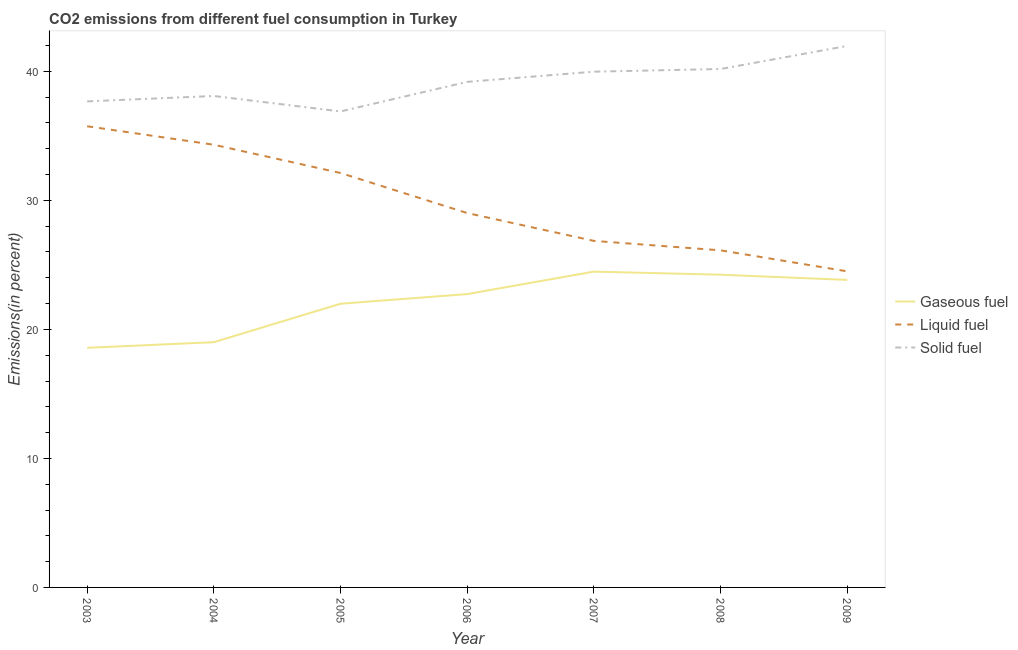Is the number of lines equal to the number of legend labels?
Your answer should be very brief. Yes. What is the percentage of gaseous fuel emission in 2006?
Provide a succinct answer. 22.74. Across all years, what is the maximum percentage of liquid fuel emission?
Make the answer very short. 35.75. Across all years, what is the minimum percentage of liquid fuel emission?
Your response must be concise. 24.5. What is the total percentage of solid fuel emission in the graph?
Provide a succinct answer. 273.98. What is the difference between the percentage of liquid fuel emission in 2006 and that in 2008?
Your answer should be compact. 2.89. What is the difference between the percentage of solid fuel emission in 2008 and the percentage of liquid fuel emission in 2003?
Your response must be concise. 4.44. What is the average percentage of solid fuel emission per year?
Offer a terse response. 39.14. In the year 2003, what is the difference between the percentage of gaseous fuel emission and percentage of solid fuel emission?
Give a very brief answer. -19.1. In how many years, is the percentage of gaseous fuel emission greater than 22 %?
Your answer should be compact. 4. What is the ratio of the percentage of solid fuel emission in 2007 to that in 2009?
Give a very brief answer. 0.95. Is the percentage of solid fuel emission in 2003 less than that in 2005?
Give a very brief answer. No. What is the difference between the highest and the second highest percentage of solid fuel emission?
Ensure brevity in your answer.  1.79. What is the difference between the highest and the lowest percentage of liquid fuel emission?
Offer a terse response. 11.25. Is it the case that in every year, the sum of the percentage of gaseous fuel emission and percentage of liquid fuel emission is greater than the percentage of solid fuel emission?
Your answer should be very brief. Yes. Does the percentage of solid fuel emission monotonically increase over the years?
Provide a succinct answer. No. Is the percentage of solid fuel emission strictly less than the percentage of gaseous fuel emission over the years?
Offer a very short reply. No. Where does the legend appear in the graph?
Your answer should be compact. Center right. How many legend labels are there?
Your response must be concise. 3. How are the legend labels stacked?
Give a very brief answer. Vertical. What is the title of the graph?
Give a very brief answer. CO2 emissions from different fuel consumption in Turkey. Does "Coal sources" appear as one of the legend labels in the graph?
Offer a terse response. No. What is the label or title of the Y-axis?
Offer a terse response. Emissions(in percent). What is the Emissions(in percent) of Gaseous fuel in 2003?
Offer a very short reply. 18.57. What is the Emissions(in percent) in Liquid fuel in 2003?
Your answer should be compact. 35.75. What is the Emissions(in percent) in Solid fuel in 2003?
Keep it short and to the point. 37.67. What is the Emissions(in percent) in Gaseous fuel in 2004?
Keep it short and to the point. 19.01. What is the Emissions(in percent) in Liquid fuel in 2004?
Keep it short and to the point. 34.31. What is the Emissions(in percent) in Solid fuel in 2004?
Provide a short and direct response. 38.09. What is the Emissions(in percent) of Gaseous fuel in 2005?
Offer a terse response. 21.99. What is the Emissions(in percent) in Liquid fuel in 2005?
Provide a short and direct response. 32.12. What is the Emissions(in percent) of Solid fuel in 2005?
Your answer should be compact. 36.9. What is the Emissions(in percent) of Gaseous fuel in 2006?
Your answer should be compact. 22.74. What is the Emissions(in percent) in Liquid fuel in 2006?
Give a very brief answer. 29.02. What is the Emissions(in percent) of Solid fuel in 2006?
Offer a very short reply. 39.19. What is the Emissions(in percent) of Gaseous fuel in 2007?
Offer a terse response. 24.48. What is the Emissions(in percent) of Liquid fuel in 2007?
Provide a short and direct response. 26.86. What is the Emissions(in percent) of Solid fuel in 2007?
Your answer should be very brief. 39.98. What is the Emissions(in percent) of Gaseous fuel in 2008?
Your response must be concise. 24.24. What is the Emissions(in percent) in Liquid fuel in 2008?
Keep it short and to the point. 26.13. What is the Emissions(in percent) of Solid fuel in 2008?
Offer a very short reply. 40.18. What is the Emissions(in percent) of Gaseous fuel in 2009?
Offer a very short reply. 23.84. What is the Emissions(in percent) of Liquid fuel in 2009?
Offer a very short reply. 24.5. What is the Emissions(in percent) in Solid fuel in 2009?
Your answer should be compact. 41.97. Across all years, what is the maximum Emissions(in percent) in Gaseous fuel?
Offer a terse response. 24.48. Across all years, what is the maximum Emissions(in percent) in Liquid fuel?
Your answer should be compact. 35.75. Across all years, what is the maximum Emissions(in percent) in Solid fuel?
Your answer should be very brief. 41.97. Across all years, what is the minimum Emissions(in percent) in Gaseous fuel?
Give a very brief answer. 18.57. Across all years, what is the minimum Emissions(in percent) of Liquid fuel?
Give a very brief answer. 24.5. Across all years, what is the minimum Emissions(in percent) of Solid fuel?
Make the answer very short. 36.9. What is the total Emissions(in percent) of Gaseous fuel in the graph?
Offer a terse response. 154.86. What is the total Emissions(in percent) in Liquid fuel in the graph?
Give a very brief answer. 208.69. What is the total Emissions(in percent) in Solid fuel in the graph?
Your answer should be very brief. 273.98. What is the difference between the Emissions(in percent) of Gaseous fuel in 2003 and that in 2004?
Offer a very short reply. -0.44. What is the difference between the Emissions(in percent) in Liquid fuel in 2003 and that in 2004?
Your answer should be very brief. 1.43. What is the difference between the Emissions(in percent) in Solid fuel in 2003 and that in 2004?
Your answer should be very brief. -0.42. What is the difference between the Emissions(in percent) of Gaseous fuel in 2003 and that in 2005?
Offer a very short reply. -3.42. What is the difference between the Emissions(in percent) of Liquid fuel in 2003 and that in 2005?
Your answer should be compact. 3.62. What is the difference between the Emissions(in percent) in Solid fuel in 2003 and that in 2005?
Keep it short and to the point. 0.78. What is the difference between the Emissions(in percent) in Gaseous fuel in 2003 and that in 2006?
Your answer should be very brief. -4.17. What is the difference between the Emissions(in percent) of Liquid fuel in 2003 and that in 2006?
Ensure brevity in your answer.  6.73. What is the difference between the Emissions(in percent) of Solid fuel in 2003 and that in 2006?
Give a very brief answer. -1.51. What is the difference between the Emissions(in percent) in Gaseous fuel in 2003 and that in 2007?
Keep it short and to the point. -5.91. What is the difference between the Emissions(in percent) of Liquid fuel in 2003 and that in 2007?
Offer a terse response. 8.88. What is the difference between the Emissions(in percent) of Solid fuel in 2003 and that in 2007?
Give a very brief answer. -2.3. What is the difference between the Emissions(in percent) in Gaseous fuel in 2003 and that in 2008?
Keep it short and to the point. -5.67. What is the difference between the Emissions(in percent) in Liquid fuel in 2003 and that in 2008?
Ensure brevity in your answer.  9.62. What is the difference between the Emissions(in percent) of Solid fuel in 2003 and that in 2008?
Make the answer very short. -2.51. What is the difference between the Emissions(in percent) in Gaseous fuel in 2003 and that in 2009?
Provide a succinct answer. -5.26. What is the difference between the Emissions(in percent) of Liquid fuel in 2003 and that in 2009?
Offer a very short reply. 11.25. What is the difference between the Emissions(in percent) in Solid fuel in 2003 and that in 2009?
Ensure brevity in your answer.  -4.3. What is the difference between the Emissions(in percent) in Gaseous fuel in 2004 and that in 2005?
Your answer should be very brief. -2.98. What is the difference between the Emissions(in percent) in Liquid fuel in 2004 and that in 2005?
Your answer should be compact. 2.19. What is the difference between the Emissions(in percent) in Solid fuel in 2004 and that in 2005?
Your answer should be compact. 1.2. What is the difference between the Emissions(in percent) of Gaseous fuel in 2004 and that in 2006?
Offer a very short reply. -3.73. What is the difference between the Emissions(in percent) of Liquid fuel in 2004 and that in 2006?
Offer a very short reply. 5.3. What is the difference between the Emissions(in percent) in Solid fuel in 2004 and that in 2006?
Provide a short and direct response. -1.09. What is the difference between the Emissions(in percent) in Gaseous fuel in 2004 and that in 2007?
Offer a very short reply. -5.47. What is the difference between the Emissions(in percent) in Liquid fuel in 2004 and that in 2007?
Ensure brevity in your answer.  7.45. What is the difference between the Emissions(in percent) in Solid fuel in 2004 and that in 2007?
Offer a very short reply. -1.88. What is the difference between the Emissions(in percent) of Gaseous fuel in 2004 and that in 2008?
Offer a very short reply. -5.23. What is the difference between the Emissions(in percent) in Liquid fuel in 2004 and that in 2008?
Offer a very short reply. 8.19. What is the difference between the Emissions(in percent) in Solid fuel in 2004 and that in 2008?
Provide a short and direct response. -2.09. What is the difference between the Emissions(in percent) in Gaseous fuel in 2004 and that in 2009?
Your answer should be compact. -4.83. What is the difference between the Emissions(in percent) of Liquid fuel in 2004 and that in 2009?
Give a very brief answer. 9.81. What is the difference between the Emissions(in percent) of Solid fuel in 2004 and that in 2009?
Make the answer very short. -3.88. What is the difference between the Emissions(in percent) of Gaseous fuel in 2005 and that in 2006?
Provide a succinct answer. -0.75. What is the difference between the Emissions(in percent) in Liquid fuel in 2005 and that in 2006?
Offer a very short reply. 3.1. What is the difference between the Emissions(in percent) of Solid fuel in 2005 and that in 2006?
Provide a short and direct response. -2.29. What is the difference between the Emissions(in percent) of Gaseous fuel in 2005 and that in 2007?
Your answer should be compact. -2.49. What is the difference between the Emissions(in percent) in Liquid fuel in 2005 and that in 2007?
Your answer should be compact. 5.26. What is the difference between the Emissions(in percent) in Solid fuel in 2005 and that in 2007?
Give a very brief answer. -3.08. What is the difference between the Emissions(in percent) of Gaseous fuel in 2005 and that in 2008?
Make the answer very short. -2.25. What is the difference between the Emissions(in percent) of Liquid fuel in 2005 and that in 2008?
Provide a succinct answer. 5.99. What is the difference between the Emissions(in percent) in Solid fuel in 2005 and that in 2008?
Offer a terse response. -3.29. What is the difference between the Emissions(in percent) in Gaseous fuel in 2005 and that in 2009?
Offer a terse response. -1.85. What is the difference between the Emissions(in percent) of Liquid fuel in 2005 and that in 2009?
Provide a succinct answer. 7.62. What is the difference between the Emissions(in percent) in Solid fuel in 2005 and that in 2009?
Give a very brief answer. -5.08. What is the difference between the Emissions(in percent) of Gaseous fuel in 2006 and that in 2007?
Give a very brief answer. -1.74. What is the difference between the Emissions(in percent) of Liquid fuel in 2006 and that in 2007?
Keep it short and to the point. 2.16. What is the difference between the Emissions(in percent) in Solid fuel in 2006 and that in 2007?
Provide a short and direct response. -0.79. What is the difference between the Emissions(in percent) of Gaseous fuel in 2006 and that in 2008?
Your answer should be very brief. -1.5. What is the difference between the Emissions(in percent) of Liquid fuel in 2006 and that in 2008?
Offer a very short reply. 2.89. What is the difference between the Emissions(in percent) in Solid fuel in 2006 and that in 2008?
Provide a short and direct response. -1. What is the difference between the Emissions(in percent) of Gaseous fuel in 2006 and that in 2009?
Provide a succinct answer. -1.1. What is the difference between the Emissions(in percent) of Liquid fuel in 2006 and that in 2009?
Make the answer very short. 4.52. What is the difference between the Emissions(in percent) in Solid fuel in 2006 and that in 2009?
Make the answer very short. -2.79. What is the difference between the Emissions(in percent) in Gaseous fuel in 2007 and that in 2008?
Ensure brevity in your answer.  0.24. What is the difference between the Emissions(in percent) of Liquid fuel in 2007 and that in 2008?
Your response must be concise. 0.73. What is the difference between the Emissions(in percent) in Solid fuel in 2007 and that in 2008?
Your response must be concise. -0.21. What is the difference between the Emissions(in percent) of Gaseous fuel in 2007 and that in 2009?
Provide a succinct answer. 0.64. What is the difference between the Emissions(in percent) in Liquid fuel in 2007 and that in 2009?
Give a very brief answer. 2.36. What is the difference between the Emissions(in percent) of Solid fuel in 2007 and that in 2009?
Your response must be concise. -2. What is the difference between the Emissions(in percent) of Gaseous fuel in 2008 and that in 2009?
Provide a short and direct response. 0.4. What is the difference between the Emissions(in percent) in Liquid fuel in 2008 and that in 2009?
Your answer should be very brief. 1.63. What is the difference between the Emissions(in percent) of Solid fuel in 2008 and that in 2009?
Your answer should be very brief. -1.79. What is the difference between the Emissions(in percent) of Gaseous fuel in 2003 and the Emissions(in percent) of Liquid fuel in 2004?
Your response must be concise. -15.74. What is the difference between the Emissions(in percent) of Gaseous fuel in 2003 and the Emissions(in percent) of Solid fuel in 2004?
Ensure brevity in your answer.  -19.52. What is the difference between the Emissions(in percent) in Liquid fuel in 2003 and the Emissions(in percent) in Solid fuel in 2004?
Offer a very short reply. -2.35. What is the difference between the Emissions(in percent) of Gaseous fuel in 2003 and the Emissions(in percent) of Liquid fuel in 2005?
Offer a terse response. -13.55. What is the difference between the Emissions(in percent) in Gaseous fuel in 2003 and the Emissions(in percent) in Solid fuel in 2005?
Give a very brief answer. -18.32. What is the difference between the Emissions(in percent) of Liquid fuel in 2003 and the Emissions(in percent) of Solid fuel in 2005?
Offer a very short reply. -1.15. What is the difference between the Emissions(in percent) of Gaseous fuel in 2003 and the Emissions(in percent) of Liquid fuel in 2006?
Give a very brief answer. -10.45. What is the difference between the Emissions(in percent) in Gaseous fuel in 2003 and the Emissions(in percent) in Solid fuel in 2006?
Give a very brief answer. -20.61. What is the difference between the Emissions(in percent) in Liquid fuel in 2003 and the Emissions(in percent) in Solid fuel in 2006?
Give a very brief answer. -3.44. What is the difference between the Emissions(in percent) of Gaseous fuel in 2003 and the Emissions(in percent) of Liquid fuel in 2007?
Give a very brief answer. -8.29. What is the difference between the Emissions(in percent) in Gaseous fuel in 2003 and the Emissions(in percent) in Solid fuel in 2007?
Your answer should be compact. -21.4. What is the difference between the Emissions(in percent) in Liquid fuel in 2003 and the Emissions(in percent) in Solid fuel in 2007?
Make the answer very short. -4.23. What is the difference between the Emissions(in percent) in Gaseous fuel in 2003 and the Emissions(in percent) in Liquid fuel in 2008?
Provide a succinct answer. -7.56. What is the difference between the Emissions(in percent) of Gaseous fuel in 2003 and the Emissions(in percent) of Solid fuel in 2008?
Ensure brevity in your answer.  -21.61. What is the difference between the Emissions(in percent) of Liquid fuel in 2003 and the Emissions(in percent) of Solid fuel in 2008?
Your answer should be compact. -4.44. What is the difference between the Emissions(in percent) of Gaseous fuel in 2003 and the Emissions(in percent) of Liquid fuel in 2009?
Offer a very short reply. -5.93. What is the difference between the Emissions(in percent) of Gaseous fuel in 2003 and the Emissions(in percent) of Solid fuel in 2009?
Give a very brief answer. -23.4. What is the difference between the Emissions(in percent) in Liquid fuel in 2003 and the Emissions(in percent) in Solid fuel in 2009?
Provide a succinct answer. -6.23. What is the difference between the Emissions(in percent) in Gaseous fuel in 2004 and the Emissions(in percent) in Liquid fuel in 2005?
Provide a short and direct response. -13.12. What is the difference between the Emissions(in percent) of Gaseous fuel in 2004 and the Emissions(in percent) of Solid fuel in 2005?
Offer a very short reply. -17.89. What is the difference between the Emissions(in percent) of Liquid fuel in 2004 and the Emissions(in percent) of Solid fuel in 2005?
Your response must be concise. -2.58. What is the difference between the Emissions(in percent) in Gaseous fuel in 2004 and the Emissions(in percent) in Liquid fuel in 2006?
Your answer should be very brief. -10.01. What is the difference between the Emissions(in percent) in Gaseous fuel in 2004 and the Emissions(in percent) in Solid fuel in 2006?
Your answer should be very brief. -20.18. What is the difference between the Emissions(in percent) in Liquid fuel in 2004 and the Emissions(in percent) in Solid fuel in 2006?
Your response must be concise. -4.87. What is the difference between the Emissions(in percent) of Gaseous fuel in 2004 and the Emissions(in percent) of Liquid fuel in 2007?
Provide a succinct answer. -7.85. What is the difference between the Emissions(in percent) in Gaseous fuel in 2004 and the Emissions(in percent) in Solid fuel in 2007?
Keep it short and to the point. -20.97. What is the difference between the Emissions(in percent) of Liquid fuel in 2004 and the Emissions(in percent) of Solid fuel in 2007?
Offer a very short reply. -5.66. What is the difference between the Emissions(in percent) of Gaseous fuel in 2004 and the Emissions(in percent) of Liquid fuel in 2008?
Give a very brief answer. -7.12. What is the difference between the Emissions(in percent) in Gaseous fuel in 2004 and the Emissions(in percent) in Solid fuel in 2008?
Give a very brief answer. -21.18. What is the difference between the Emissions(in percent) in Liquid fuel in 2004 and the Emissions(in percent) in Solid fuel in 2008?
Make the answer very short. -5.87. What is the difference between the Emissions(in percent) in Gaseous fuel in 2004 and the Emissions(in percent) in Liquid fuel in 2009?
Provide a succinct answer. -5.49. What is the difference between the Emissions(in percent) of Gaseous fuel in 2004 and the Emissions(in percent) of Solid fuel in 2009?
Give a very brief answer. -22.97. What is the difference between the Emissions(in percent) of Liquid fuel in 2004 and the Emissions(in percent) of Solid fuel in 2009?
Offer a very short reply. -7.66. What is the difference between the Emissions(in percent) of Gaseous fuel in 2005 and the Emissions(in percent) of Liquid fuel in 2006?
Provide a succinct answer. -7.03. What is the difference between the Emissions(in percent) of Gaseous fuel in 2005 and the Emissions(in percent) of Solid fuel in 2006?
Your answer should be very brief. -17.2. What is the difference between the Emissions(in percent) in Liquid fuel in 2005 and the Emissions(in percent) in Solid fuel in 2006?
Make the answer very short. -7.06. What is the difference between the Emissions(in percent) of Gaseous fuel in 2005 and the Emissions(in percent) of Liquid fuel in 2007?
Make the answer very short. -4.87. What is the difference between the Emissions(in percent) of Gaseous fuel in 2005 and the Emissions(in percent) of Solid fuel in 2007?
Your answer should be very brief. -17.99. What is the difference between the Emissions(in percent) of Liquid fuel in 2005 and the Emissions(in percent) of Solid fuel in 2007?
Your response must be concise. -7.85. What is the difference between the Emissions(in percent) in Gaseous fuel in 2005 and the Emissions(in percent) in Liquid fuel in 2008?
Ensure brevity in your answer.  -4.14. What is the difference between the Emissions(in percent) in Gaseous fuel in 2005 and the Emissions(in percent) in Solid fuel in 2008?
Keep it short and to the point. -18.19. What is the difference between the Emissions(in percent) in Liquid fuel in 2005 and the Emissions(in percent) in Solid fuel in 2008?
Offer a terse response. -8.06. What is the difference between the Emissions(in percent) in Gaseous fuel in 2005 and the Emissions(in percent) in Liquid fuel in 2009?
Offer a very short reply. -2.51. What is the difference between the Emissions(in percent) of Gaseous fuel in 2005 and the Emissions(in percent) of Solid fuel in 2009?
Your response must be concise. -19.98. What is the difference between the Emissions(in percent) of Liquid fuel in 2005 and the Emissions(in percent) of Solid fuel in 2009?
Ensure brevity in your answer.  -9.85. What is the difference between the Emissions(in percent) in Gaseous fuel in 2006 and the Emissions(in percent) in Liquid fuel in 2007?
Your response must be concise. -4.12. What is the difference between the Emissions(in percent) of Gaseous fuel in 2006 and the Emissions(in percent) of Solid fuel in 2007?
Give a very brief answer. -17.24. What is the difference between the Emissions(in percent) of Liquid fuel in 2006 and the Emissions(in percent) of Solid fuel in 2007?
Your answer should be very brief. -10.96. What is the difference between the Emissions(in percent) of Gaseous fuel in 2006 and the Emissions(in percent) of Liquid fuel in 2008?
Provide a succinct answer. -3.39. What is the difference between the Emissions(in percent) of Gaseous fuel in 2006 and the Emissions(in percent) of Solid fuel in 2008?
Your response must be concise. -17.45. What is the difference between the Emissions(in percent) of Liquid fuel in 2006 and the Emissions(in percent) of Solid fuel in 2008?
Make the answer very short. -11.16. What is the difference between the Emissions(in percent) in Gaseous fuel in 2006 and the Emissions(in percent) in Liquid fuel in 2009?
Offer a terse response. -1.76. What is the difference between the Emissions(in percent) of Gaseous fuel in 2006 and the Emissions(in percent) of Solid fuel in 2009?
Provide a short and direct response. -19.24. What is the difference between the Emissions(in percent) in Liquid fuel in 2006 and the Emissions(in percent) in Solid fuel in 2009?
Give a very brief answer. -12.95. What is the difference between the Emissions(in percent) of Gaseous fuel in 2007 and the Emissions(in percent) of Liquid fuel in 2008?
Your answer should be very brief. -1.65. What is the difference between the Emissions(in percent) of Gaseous fuel in 2007 and the Emissions(in percent) of Solid fuel in 2008?
Make the answer very short. -15.71. What is the difference between the Emissions(in percent) in Liquid fuel in 2007 and the Emissions(in percent) in Solid fuel in 2008?
Your response must be concise. -13.32. What is the difference between the Emissions(in percent) in Gaseous fuel in 2007 and the Emissions(in percent) in Liquid fuel in 2009?
Ensure brevity in your answer.  -0.02. What is the difference between the Emissions(in percent) in Gaseous fuel in 2007 and the Emissions(in percent) in Solid fuel in 2009?
Your answer should be compact. -17.5. What is the difference between the Emissions(in percent) in Liquid fuel in 2007 and the Emissions(in percent) in Solid fuel in 2009?
Offer a very short reply. -15.11. What is the difference between the Emissions(in percent) in Gaseous fuel in 2008 and the Emissions(in percent) in Liquid fuel in 2009?
Provide a short and direct response. -0.26. What is the difference between the Emissions(in percent) of Gaseous fuel in 2008 and the Emissions(in percent) of Solid fuel in 2009?
Make the answer very short. -17.73. What is the difference between the Emissions(in percent) in Liquid fuel in 2008 and the Emissions(in percent) in Solid fuel in 2009?
Offer a terse response. -15.84. What is the average Emissions(in percent) in Gaseous fuel per year?
Your answer should be very brief. 22.12. What is the average Emissions(in percent) of Liquid fuel per year?
Provide a short and direct response. 29.81. What is the average Emissions(in percent) of Solid fuel per year?
Offer a terse response. 39.14. In the year 2003, what is the difference between the Emissions(in percent) in Gaseous fuel and Emissions(in percent) in Liquid fuel?
Offer a terse response. -17.17. In the year 2003, what is the difference between the Emissions(in percent) in Gaseous fuel and Emissions(in percent) in Solid fuel?
Provide a short and direct response. -19.1. In the year 2003, what is the difference between the Emissions(in percent) in Liquid fuel and Emissions(in percent) in Solid fuel?
Provide a succinct answer. -1.93. In the year 2004, what is the difference between the Emissions(in percent) in Gaseous fuel and Emissions(in percent) in Liquid fuel?
Give a very brief answer. -15.31. In the year 2004, what is the difference between the Emissions(in percent) of Gaseous fuel and Emissions(in percent) of Solid fuel?
Ensure brevity in your answer.  -19.08. In the year 2004, what is the difference between the Emissions(in percent) in Liquid fuel and Emissions(in percent) in Solid fuel?
Offer a very short reply. -3.78. In the year 2005, what is the difference between the Emissions(in percent) of Gaseous fuel and Emissions(in percent) of Liquid fuel?
Make the answer very short. -10.13. In the year 2005, what is the difference between the Emissions(in percent) in Gaseous fuel and Emissions(in percent) in Solid fuel?
Your answer should be very brief. -14.91. In the year 2005, what is the difference between the Emissions(in percent) of Liquid fuel and Emissions(in percent) of Solid fuel?
Give a very brief answer. -4.77. In the year 2006, what is the difference between the Emissions(in percent) in Gaseous fuel and Emissions(in percent) in Liquid fuel?
Provide a short and direct response. -6.28. In the year 2006, what is the difference between the Emissions(in percent) in Gaseous fuel and Emissions(in percent) in Solid fuel?
Your answer should be compact. -16.45. In the year 2006, what is the difference between the Emissions(in percent) of Liquid fuel and Emissions(in percent) of Solid fuel?
Provide a succinct answer. -10.17. In the year 2007, what is the difference between the Emissions(in percent) in Gaseous fuel and Emissions(in percent) in Liquid fuel?
Your answer should be compact. -2.38. In the year 2007, what is the difference between the Emissions(in percent) in Gaseous fuel and Emissions(in percent) in Solid fuel?
Keep it short and to the point. -15.5. In the year 2007, what is the difference between the Emissions(in percent) of Liquid fuel and Emissions(in percent) of Solid fuel?
Offer a terse response. -13.12. In the year 2008, what is the difference between the Emissions(in percent) of Gaseous fuel and Emissions(in percent) of Liquid fuel?
Keep it short and to the point. -1.89. In the year 2008, what is the difference between the Emissions(in percent) of Gaseous fuel and Emissions(in percent) of Solid fuel?
Offer a terse response. -15.94. In the year 2008, what is the difference between the Emissions(in percent) of Liquid fuel and Emissions(in percent) of Solid fuel?
Give a very brief answer. -14.05. In the year 2009, what is the difference between the Emissions(in percent) of Gaseous fuel and Emissions(in percent) of Liquid fuel?
Offer a very short reply. -0.66. In the year 2009, what is the difference between the Emissions(in percent) in Gaseous fuel and Emissions(in percent) in Solid fuel?
Keep it short and to the point. -18.14. In the year 2009, what is the difference between the Emissions(in percent) in Liquid fuel and Emissions(in percent) in Solid fuel?
Offer a very short reply. -17.47. What is the ratio of the Emissions(in percent) in Gaseous fuel in 2003 to that in 2004?
Keep it short and to the point. 0.98. What is the ratio of the Emissions(in percent) of Liquid fuel in 2003 to that in 2004?
Your answer should be very brief. 1.04. What is the ratio of the Emissions(in percent) of Gaseous fuel in 2003 to that in 2005?
Keep it short and to the point. 0.84. What is the ratio of the Emissions(in percent) in Liquid fuel in 2003 to that in 2005?
Your answer should be very brief. 1.11. What is the ratio of the Emissions(in percent) in Solid fuel in 2003 to that in 2005?
Offer a very short reply. 1.02. What is the ratio of the Emissions(in percent) of Gaseous fuel in 2003 to that in 2006?
Keep it short and to the point. 0.82. What is the ratio of the Emissions(in percent) in Liquid fuel in 2003 to that in 2006?
Give a very brief answer. 1.23. What is the ratio of the Emissions(in percent) in Solid fuel in 2003 to that in 2006?
Your answer should be very brief. 0.96. What is the ratio of the Emissions(in percent) in Gaseous fuel in 2003 to that in 2007?
Your response must be concise. 0.76. What is the ratio of the Emissions(in percent) in Liquid fuel in 2003 to that in 2007?
Give a very brief answer. 1.33. What is the ratio of the Emissions(in percent) of Solid fuel in 2003 to that in 2007?
Provide a succinct answer. 0.94. What is the ratio of the Emissions(in percent) in Gaseous fuel in 2003 to that in 2008?
Provide a succinct answer. 0.77. What is the ratio of the Emissions(in percent) in Liquid fuel in 2003 to that in 2008?
Ensure brevity in your answer.  1.37. What is the ratio of the Emissions(in percent) in Solid fuel in 2003 to that in 2008?
Offer a very short reply. 0.94. What is the ratio of the Emissions(in percent) of Gaseous fuel in 2003 to that in 2009?
Give a very brief answer. 0.78. What is the ratio of the Emissions(in percent) of Liquid fuel in 2003 to that in 2009?
Offer a very short reply. 1.46. What is the ratio of the Emissions(in percent) in Solid fuel in 2003 to that in 2009?
Make the answer very short. 0.9. What is the ratio of the Emissions(in percent) in Gaseous fuel in 2004 to that in 2005?
Offer a terse response. 0.86. What is the ratio of the Emissions(in percent) in Liquid fuel in 2004 to that in 2005?
Your answer should be very brief. 1.07. What is the ratio of the Emissions(in percent) in Solid fuel in 2004 to that in 2005?
Your answer should be compact. 1.03. What is the ratio of the Emissions(in percent) of Gaseous fuel in 2004 to that in 2006?
Keep it short and to the point. 0.84. What is the ratio of the Emissions(in percent) in Liquid fuel in 2004 to that in 2006?
Keep it short and to the point. 1.18. What is the ratio of the Emissions(in percent) in Solid fuel in 2004 to that in 2006?
Offer a very short reply. 0.97. What is the ratio of the Emissions(in percent) in Gaseous fuel in 2004 to that in 2007?
Offer a very short reply. 0.78. What is the ratio of the Emissions(in percent) of Liquid fuel in 2004 to that in 2007?
Your answer should be very brief. 1.28. What is the ratio of the Emissions(in percent) of Solid fuel in 2004 to that in 2007?
Provide a short and direct response. 0.95. What is the ratio of the Emissions(in percent) in Gaseous fuel in 2004 to that in 2008?
Keep it short and to the point. 0.78. What is the ratio of the Emissions(in percent) of Liquid fuel in 2004 to that in 2008?
Offer a terse response. 1.31. What is the ratio of the Emissions(in percent) of Solid fuel in 2004 to that in 2008?
Offer a very short reply. 0.95. What is the ratio of the Emissions(in percent) of Gaseous fuel in 2004 to that in 2009?
Provide a succinct answer. 0.8. What is the ratio of the Emissions(in percent) in Liquid fuel in 2004 to that in 2009?
Ensure brevity in your answer.  1.4. What is the ratio of the Emissions(in percent) in Solid fuel in 2004 to that in 2009?
Provide a short and direct response. 0.91. What is the ratio of the Emissions(in percent) of Gaseous fuel in 2005 to that in 2006?
Give a very brief answer. 0.97. What is the ratio of the Emissions(in percent) in Liquid fuel in 2005 to that in 2006?
Your answer should be very brief. 1.11. What is the ratio of the Emissions(in percent) of Solid fuel in 2005 to that in 2006?
Offer a very short reply. 0.94. What is the ratio of the Emissions(in percent) in Gaseous fuel in 2005 to that in 2007?
Offer a very short reply. 0.9. What is the ratio of the Emissions(in percent) in Liquid fuel in 2005 to that in 2007?
Your response must be concise. 1.2. What is the ratio of the Emissions(in percent) in Solid fuel in 2005 to that in 2007?
Offer a terse response. 0.92. What is the ratio of the Emissions(in percent) of Gaseous fuel in 2005 to that in 2008?
Your answer should be very brief. 0.91. What is the ratio of the Emissions(in percent) of Liquid fuel in 2005 to that in 2008?
Provide a succinct answer. 1.23. What is the ratio of the Emissions(in percent) of Solid fuel in 2005 to that in 2008?
Offer a very short reply. 0.92. What is the ratio of the Emissions(in percent) in Gaseous fuel in 2005 to that in 2009?
Give a very brief answer. 0.92. What is the ratio of the Emissions(in percent) in Liquid fuel in 2005 to that in 2009?
Provide a succinct answer. 1.31. What is the ratio of the Emissions(in percent) in Solid fuel in 2005 to that in 2009?
Keep it short and to the point. 0.88. What is the ratio of the Emissions(in percent) in Gaseous fuel in 2006 to that in 2007?
Provide a short and direct response. 0.93. What is the ratio of the Emissions(in percent) of Liquid fuel in 2006 to that in 2007?
Provide a succinct answer. 1.08. What is the ratio of the Emissions(in percent) in Solid fuel in 2006 to that in 2007?
Your response must be concise. 0.98. What is the ratio of the Emissions(in percent) of Gaseous fuel in 2006 to that in 2008?
Your response must be concise. 0.94. What is the ratio of the Emissions(in percent) in Liquid fuel in 2006 to that in 2008?
Your response must be concise. 1.11. What is the ratio of the Emissions(in percent) of Solid fuel in 2006 to that in 2008?
Your answer should be compact. 0.98. What is the ratio of the Emissions(in percent) of Gaseous fuel in 2006 to that in 2009?
Your response must be concise. 0.95. What is the ratio of the Emissions(in percent) of Liquid fuel in 2006 to that in 2009?
Make the answer very short. 1.18. What is the ratio of the Emissions(in percent) of Solid fuel in 2006 to that in 2009?
Give a very brief answer. 0.93. What is the ratio of the Emissions(in percent) of Gaseous fuel in 2007 to that in 2008?
Give a very brief answer. 1.01. What is the ratio of the Emissions(in percent) in Liquid fuel in 2007 to that in 2008?
Your response must be concise. 1.03. What is the ratio of the Emissions(in percent) in Solid fuel in 2007 to that in 2008?
Provide a short and direct response. 0.99. What is the ratio of the Emissions(in percent) of Gaseous fuel in 2007 to that in 2009?
Keep it short and to the point. 1.03. What is the ratio of the Emissions(in percent) of Liquid fuel in 2007 to that in 2009?
Your answer should be very brief. 1.1. What is the ratio of the Emissions(in percent) of Gaseous fuel in 2008 to that in 2009?
Provide a short and direct response. 1.02. What is the ratio of the Emissions(in percent) in Liquid fuel in 2008 to that in 2009?
Provide a succinct answer. 1.07. What is the ratio of the Emissions(in percent) in Solid fuel in 2008 to that in 2009?
Give a very brief answer. 0.96. What is the difference between the highest and the second highest Emissions(in percent) of Gaseous fuel?
Your answer should be very brief. 0.24. What is the difference between the highest and the second highest Emissions(in percent) in Liquid fuel?
Give a very brief answer. 1.43. What is the difference between the highest and the second highest Emissions(in percent) of Solid fuel?
Provide a succinct answer. 1.79. What is the difference between the highest and the lowest Emissions(in percent) in Gaseous fuel?
Your response must be concise. 5.91. What is the difference between the highest and the lowest Emissions(in percent) of Liquid fuel?
Provide a short and direct response. 11.25. What is the difference between the highest and the lowest Emissions(in percent) in Solid fuel?
Your answer should be compact. 5.08. 